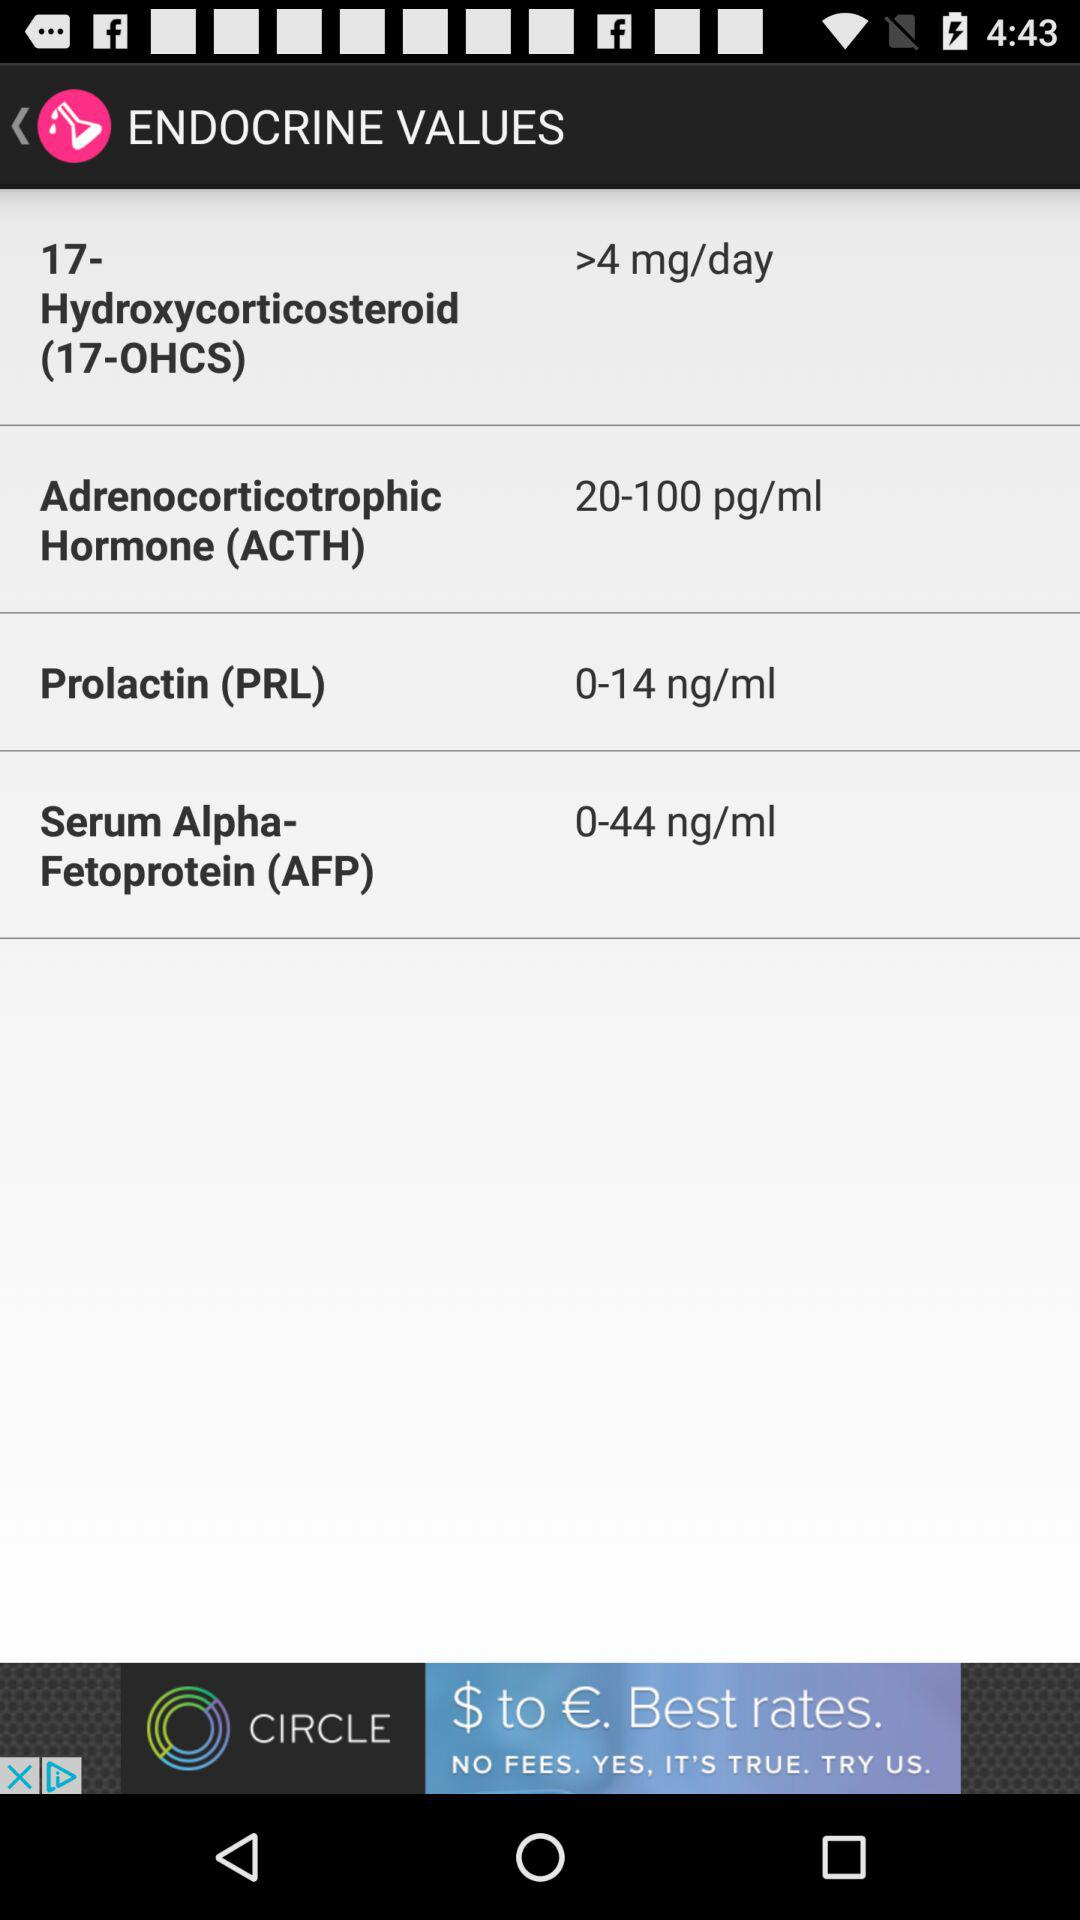What is the value of 17-Hydroxycorticosteroid (17-OHCS) per day? The value is more than 4 mg. 